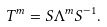<formula> <loc_0><loc_0><loc_500><loc_500>T ^ { m } = S \Lambda ^ { m } S ^ { - 1 } .</formula> 